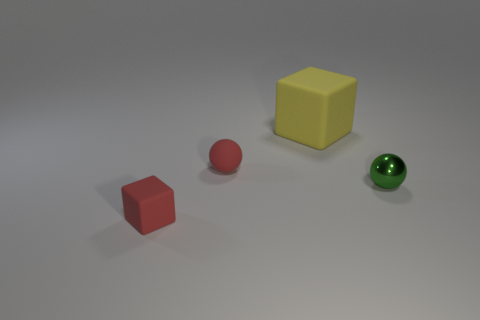There is a red block that is the same material as the big thing; what is its size?
Offer a terse response. Small. What number of yellow matte cubes are on the right side of the small object in front of the tiny shiny ball?
Provide a short and direct response. 1. Is there another yellow object of the same shape as the large object?
Offer a very short reply. No. There is a matte ball right of the red rubber thing on the left side of the tiny matte sphere; what is its color?
Give a very brief answer. Red. Is the number of tiny balls greater than the number of small purple metal cubes?
Offer a terse response. Yes. How many red balls have the same size as the green metallic thing?
Your answer should be compact. 1. Are the tiny green thing and the tiny thing to the left of the red sphere made of the same material?
Make the answer very short. No. Are there fewer small things than large rubber cubes?
Offer a very short reply. No. Is there anything else that is the same color as the rubber ball?
Give a very brief answer. Yes. There is a small thing that is the same material as the small red block; what shape is it?
Provide a short and direct response. Sphere. 